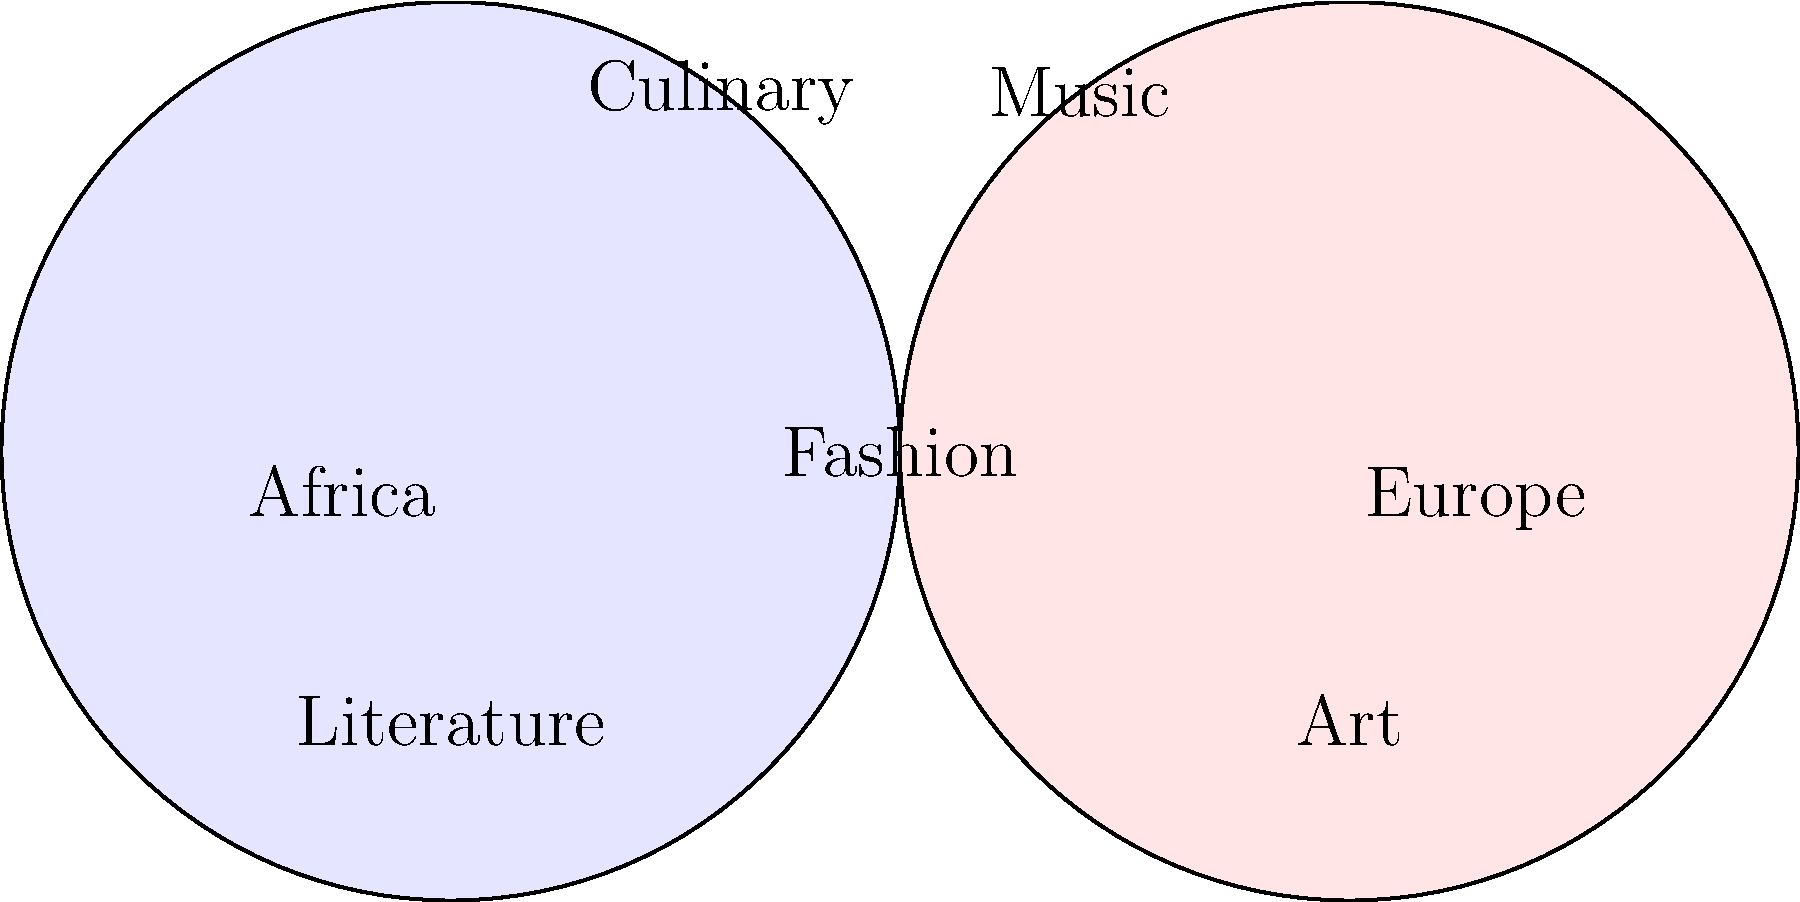Analyze the Venn diagram illustrating cultural influences between Africa and Europe. Which element is positioned at the intersection, suggesting a strong mutual influence in both African and European cultures? To answer this question, we need to carefully examine the Venn diagram and understand its components:

1. The diagram consists of two overlapping circles, representing Africa and Europe.
2. The overlapping area indicates shared cultural influences or elements that have been mutually exchanged between the two continents.
3. The elements listed in the diagram are:
   a. Culinary (in the Africa circle)
   b. Music (in the Europe circle)
   c. Fashion (in the overlapping area)
   d. Literature (in the Africa circle)
   e. Art (in the Europe circle)

4. The element positioned at the intersection of the two circles is Fashion.
5. This positioning suggests that Fashion has been a strong point of mutual influence between African and European cultures.
6. The placement of Fashion in the overlapping area implies that there has been a significant exchange of fashion ideas, styles, and trends between Africa and Europe throughout their shared history.

This mutual influence in fashion can be observed in various historical and contemporary contexts, such as:
- The incorporation of African textiles and patterns in European haute couture
- The adoption of European styles in African urban fashion
- The fusion of traditional African garments with European tailoring techniques

Therefore, based on the Venn diagram, Fashion is the element that demonstrates the strongest mutual influence between African and European cultures.
Answer: Fashion 